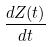<formula> <loc_0><loc_0><loc_500><loc_500>\frac { d Z ( t ) } { d t }</formula> 